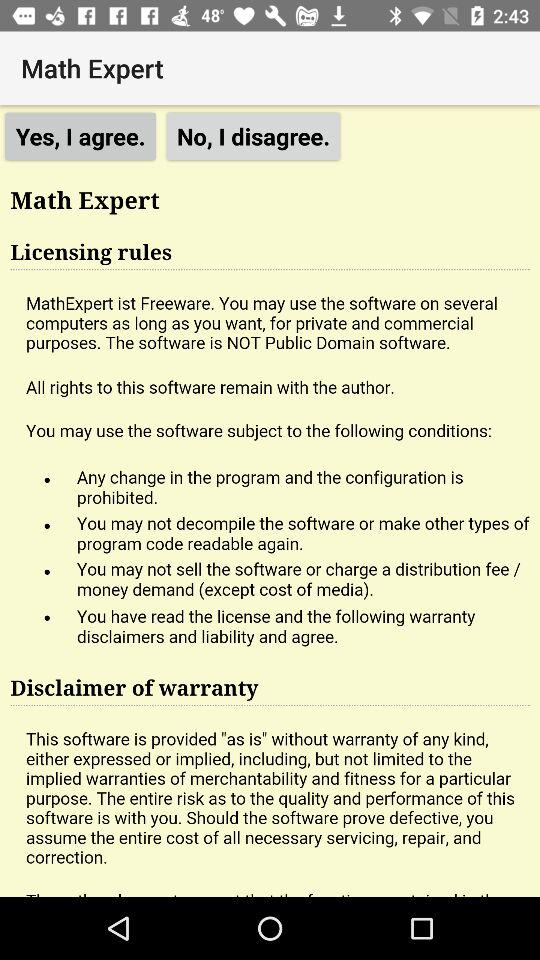What is the application name? The application name is "Math Expert". 